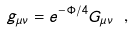Convert formula to latex. <formula><loc_0><loc_0><loc_500><loc_500>g _ { \mu \nu } = e ^ { - \Phi / 4 } G _ { \mu \nu } \ ,</formula> 